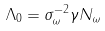Convert formula to latex. <formula><loc_0><loc_0><loc_500><loc_500>\Lambda _ { 0 } = \sigma _ { \omega } ^ { - 2 } \gamma N _ { \omega }</formula> 